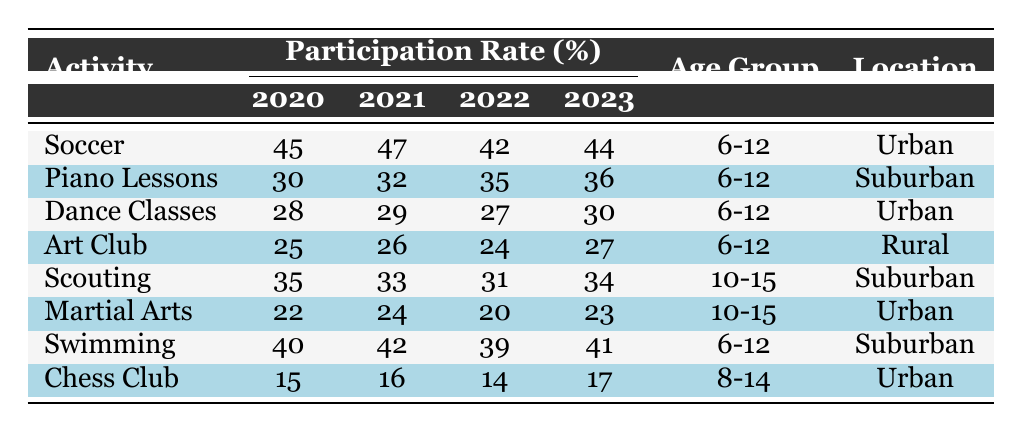What was the highest participation rate for Soccer? In the table, the participation rates for Soccer are 45% (2020), 47% (2021), 42% (2022), and 44% (2023). The highest of these values is 47% in 2021.
Answer: 47% In which year did Piano Lessons see the most significant increase in participation rate? The participation rates for Piano Lessons are 30% (2020), 32% (2021), 35% (2022), and 36% (2023). The largest increase occurred from 2020 to 2022, with an increase of 5%.
Answer: 2022 What is the average participation rate for the Dance Classes over the four years? The participation rates for Dance Classes are 28% (2020), 29% (2021), 27% (2022), and 30% (2023). Adding these values gives 28 + 29 + 27 + 30 = 114. Dividing by 4, the average is 114/4 = 28.5.
Answer: 28.5% Did the participation rate for Scouting decrease at any point in the survey period? The participation rates for Scouting are 35% (2020), 33% (2021), 31% (2022), and 34% (2023). The rate decreased from 35% to 33% from 2020 to 2021, and from 33% to 31% from 2021 to 2022, which indicates a decrease.
Answer: Yes What was the total participation rate for all activities in 2023? The participation rates for 2023 are Soccer (44%), Piano Lessons (36%), Dance Classes (30%), Art Club (27%), Scouting (34%), Martial Arts (23%), Swimming (41%), and Chess Club (17%). Summing these gives 44 + 36 + 30 + 27 + 34 + 23 + 41 + 17 = 252.
Answer: 252 Which activity had the lowest participation rate in 2020? Checking the rates for 2020: Soccer (45%), Piano Lessons (30%), Dance Classes (28%), Art Club (25%), Scouting (35%), Martial Arts (22%), Swimming (40%), and Chess Club (15%), Chess Club has the lowest participation rate at 15%.
Answer: Chess Club What was the overall trend for Swimming from 2020 to 2023? The participation rates for Swimming are 40% (2020), 42% (2021), 39% (2022), and 41% (2023). The trend showed an increase from 40% to 42%, a decrease to 39%, and then an increase to 41%, indicating fluctuations without a clear overall trend.
Answer: Fluctuated Which activity had the highest participation rate in 2021? The rates in 2021 are Soccer (47%), Piano Lessons (32%), Dance Classes (29%), Art Club (26%), Scouting (33%), Martial Arts (24%), Swimming (42%), and Chess Club (16%). Soccer had the highest participation rate at 47% in 2021.
Answer: Soccer What was the decline in participation rate for Martial Arts from 2020 to 2022? For Martial Arts, the participation rates are 22% (2020), 24% (2021), and 20% (2022). From 2020 to 2022, the decline was from 22% to 20% which is a decline of 2%.
Answer: 2% 